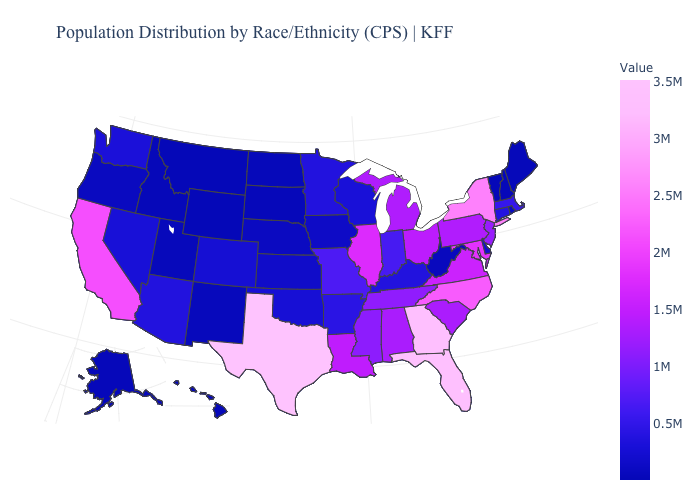Which states have the lowest value in the USA?
Answer briefly. Montana. Does Wyoming have the highest value in the West?
Quick response, please. No. Which states have the lowest value in the Northeast?
Be succinct. Vermont. Does Montana have the lowest value in the West?
Concise answer only. Yes. 